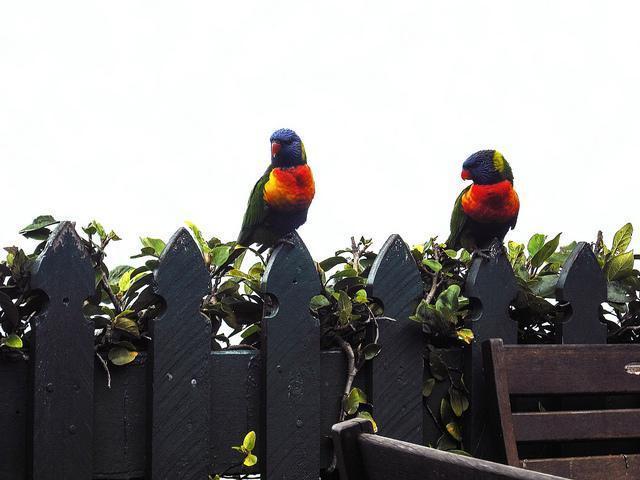How many birds are in the picture?
Give a very brief answer. 2. 